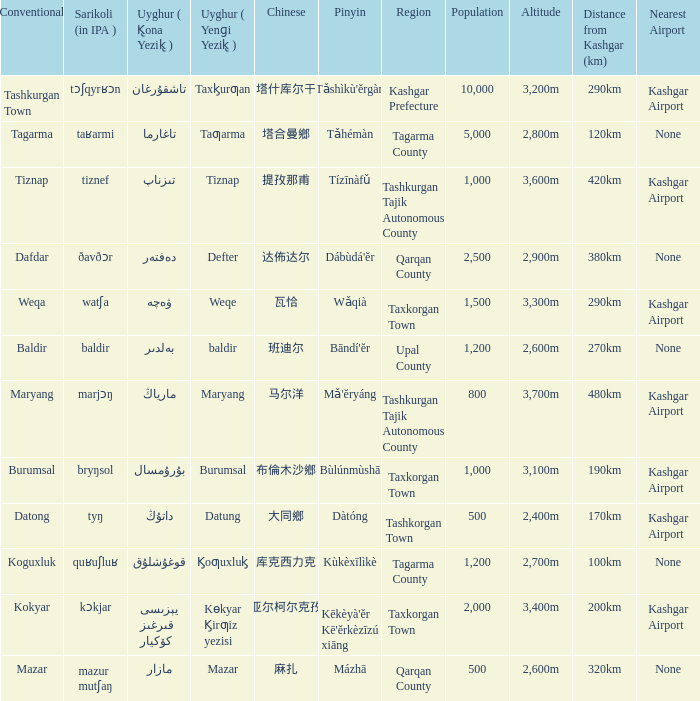Name the uyghur for  瓦恰 ۋەچە. 